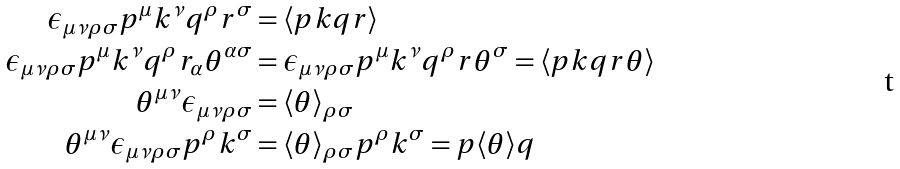<formula> <loc_0><loc_0><loc_500><loc_500>\epsilon _ { \mu \nu \rho \sigma } p ^ { \mu } k ^ { \nu } q ^ { \rho } r ^ { \sigma } & = \langle p k q r \rangle \\ \epsilon _ { \mu \nu \rho \sigma } p ^ { \mu } k ^ { \nu } q ^ { \rho } r _ { \alpha } \theta ^ { \alpha \sigma } & = \epsilon _ { \mu \nu \rho \sigma } p ^ { \mu } k ^ { \nu } q ^ { \rho } r \theta ^ { \sigma } = \langle p k q r \theta \rangle \\ \theta ^ { \mu \nu } \epsilon _ { \mu \nu \rho \sigma } & = \langle \theta \rangle _ { \rho \sigma } \\ \theta ^ { \mu \nu } \epsilon _ { \mu \nu \rho \sigma } p ^ { \rho } k ^ { \sigma } & = \langle \theta \rangle _ { \rho \sigma } p ^ { \rho } k ^ { \sigma } = p \langle \theta \rangle q</formula> 